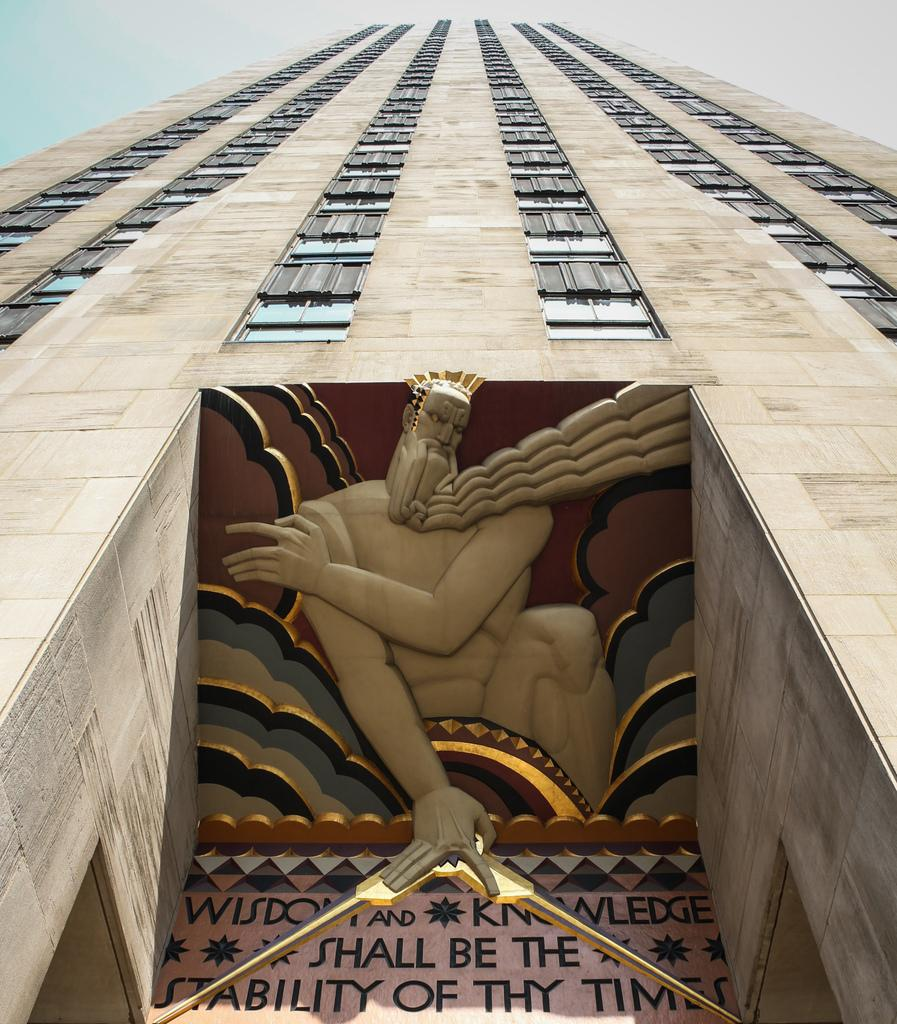What is the main subject of the image? The main subject of the image is a building. What features can be observed on the building? The building has windows and visible text. What is the owner's tendency to leave the trail when walking their dog? There is no information about an owner or a dog in the image, so it is impossible to determine their tendencies or actions. 